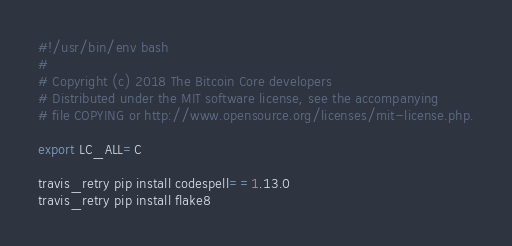Convert code to text. <code><loc_0><loc_0><loc_500><loc_500><_Bash_>#!/usr/bin/env bash
#
# Copyright (c) 2018 The Bitcoin Core developers
# Distributed under the MIT software license, see the accompanying
# file COPYING or http://www.opensource.org/licenses/mit-license.php.

export LC_ALL=C

travis_retry pip install codespell==1.13.0
travis_retry pip install flake8
</code> 